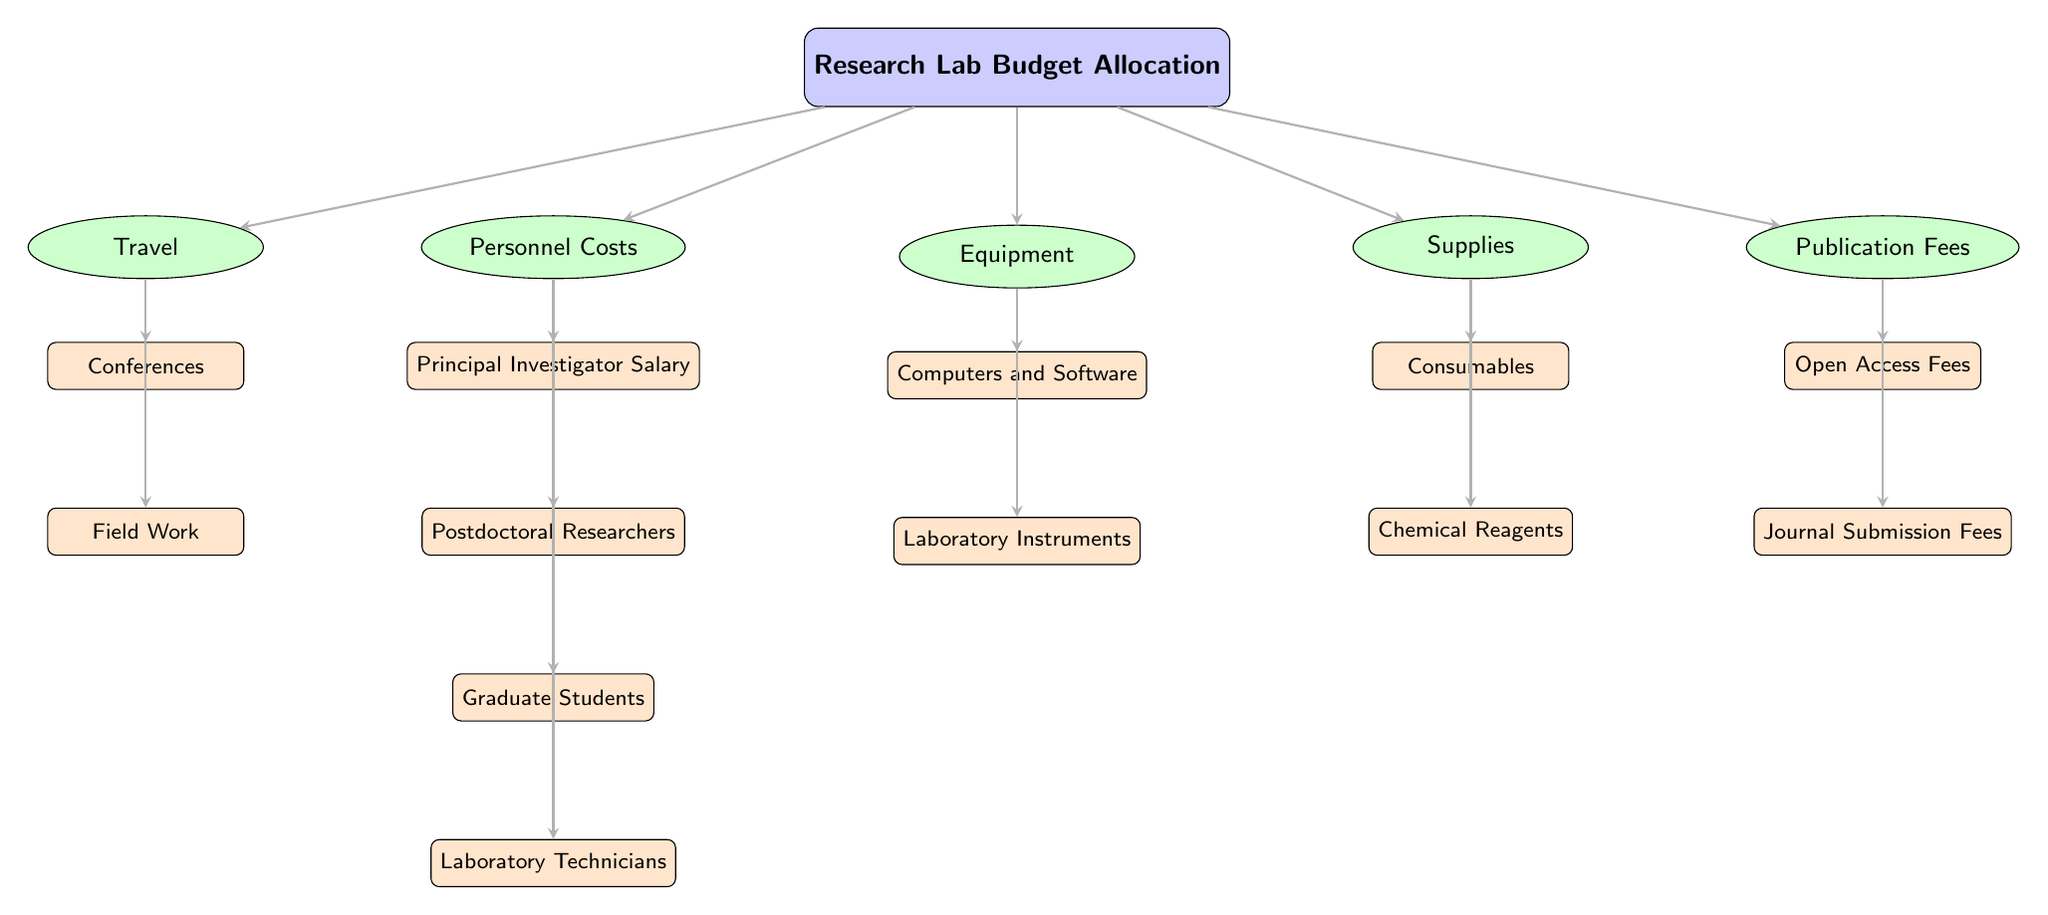What are the main categories of expenses in the research lab budget? The diagram identifies five main categories of expenses: Personnel Costs, Equipment, Supplies, Travel, and Publication Fees. These categories are the first layer beneath the main node labeled "Research Lab Budget Allocation."
Answer: Personnel Costs, Equipment, Supplies, Travel, Publication Fees How many subcategories are listed under Personnel Costs? Under Personnel Costs, there are four subcategories represented: Principal Investigator Salary, Postdoctoral Researchers, Graduate Students, and Laboratory Technicians. The counting of these subcategories gives a total of four.
Answer: Four What connects Publication Fees to the main budget allocation? The edge that connects Publication Fees to the main budget allocation demonstrates that Publication Fees are a direct component of the overall budget. This edge illustrates the hierarchical relationship between the main budget and its individual components.
Answer: Edge Which category has both consumables and reagents as subcategories? Supplies contains both consumables and reagents as its subcategories. This can be seen clearly in the diagram where both terms are listed below Supplies, indicating they fall under that category.
Answer: Supplies What is the relationship between Travel and Field Work? Field Work is a subcategory directly under Travel, indicating it is a specific type of travel expense. The arrow from Travel to Field Work demonstrates this subordinate relationship.
Answer: Subcategory How many total subcategories are there in the diagram across all main categories? The total number of subcategories can be counted from each main category: Personnel Costs (4), Equipment (2), Supplies (2), Travel (2), and Publication Fees (2). Adding these gives a total of 12 subcategories in the entire diagram.
Answer: Twelve What is the color scheme used for the main categories in the diagram? The main categories in the diagram are depicted with a blue fill color. This visual differentiation helps to distinguish these major expense areas from the subcategories below them, which are in green and orange.
Answer: Blue Which subcategory is at the bottom of the Personnel Costs? The subcategory at the bottom of Personnel Costs is Laboratory Technicians, as it is the last listed item beneath the others in the diagram. This layout indicates it is the least prioritized expense in that category among the options presented.
Answer: Laboratory Technicians 